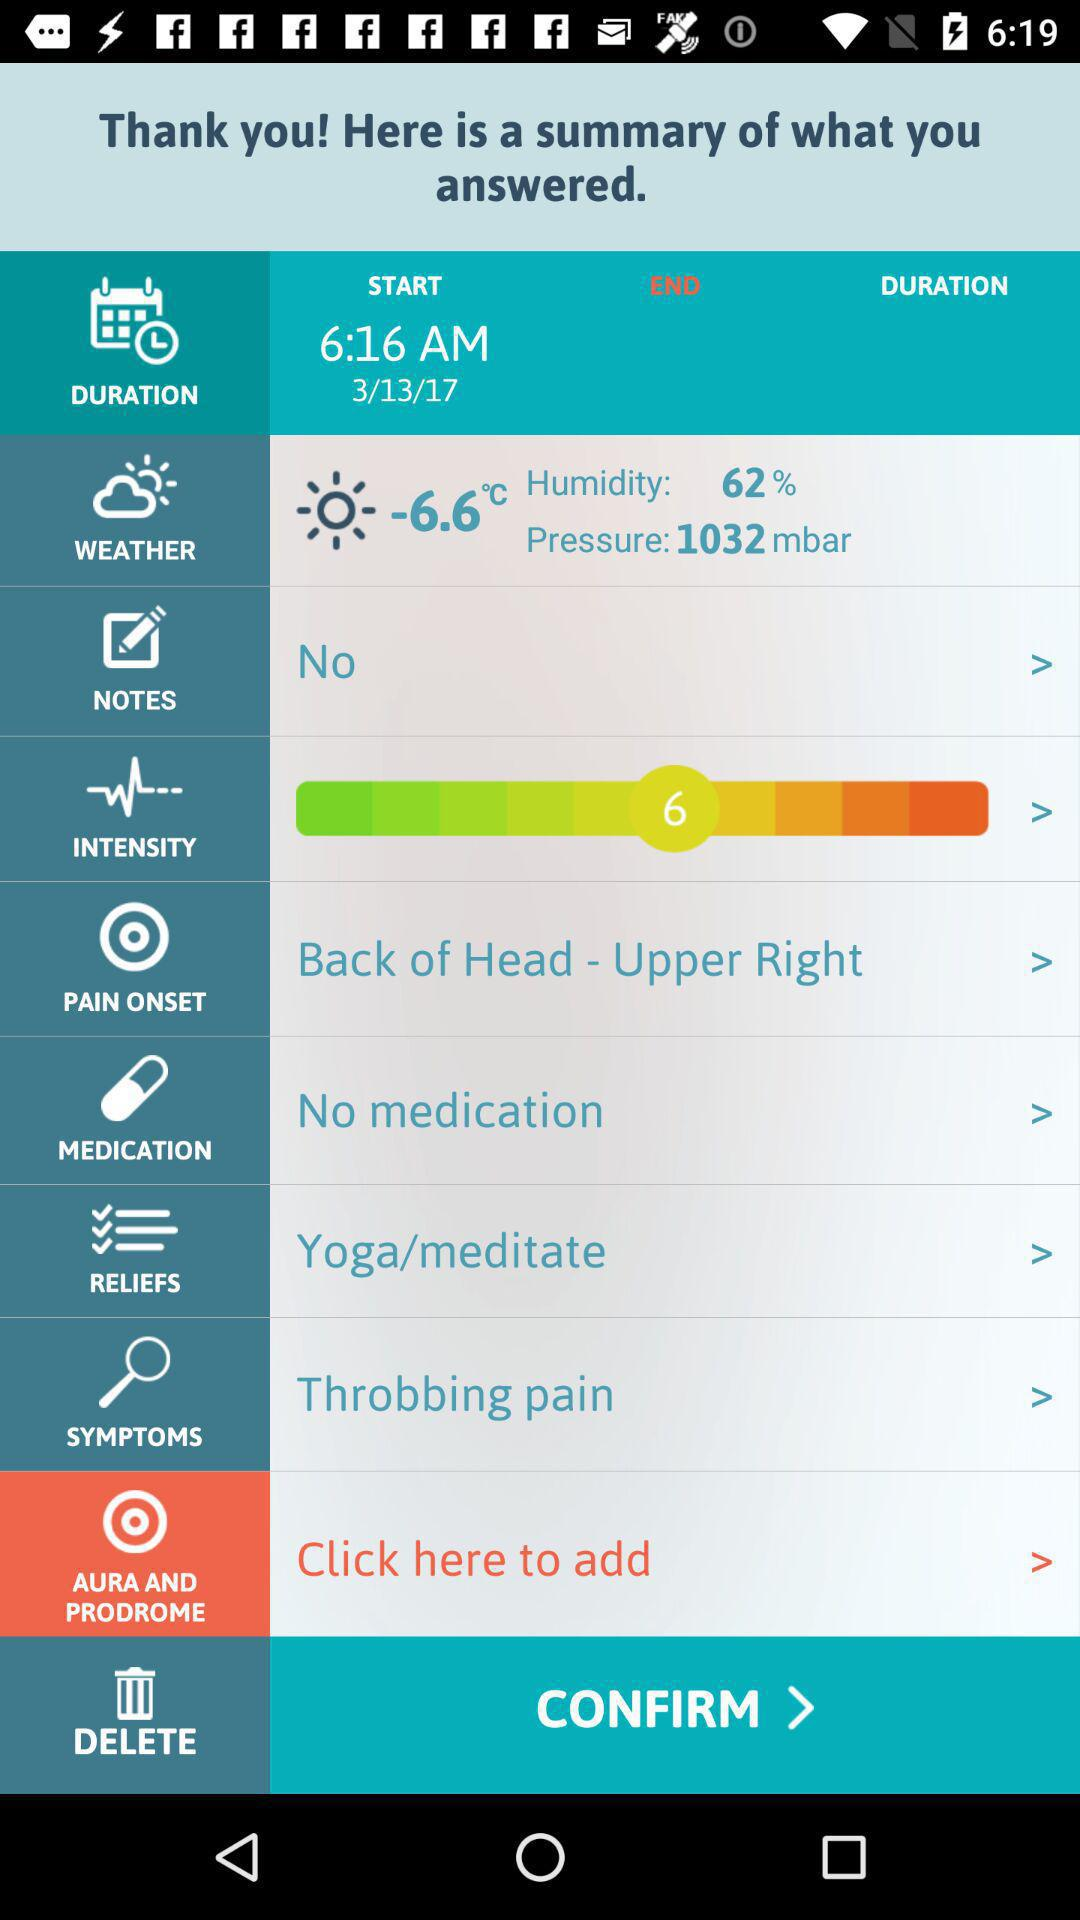What is the intensity level? The intensity level is 6. 